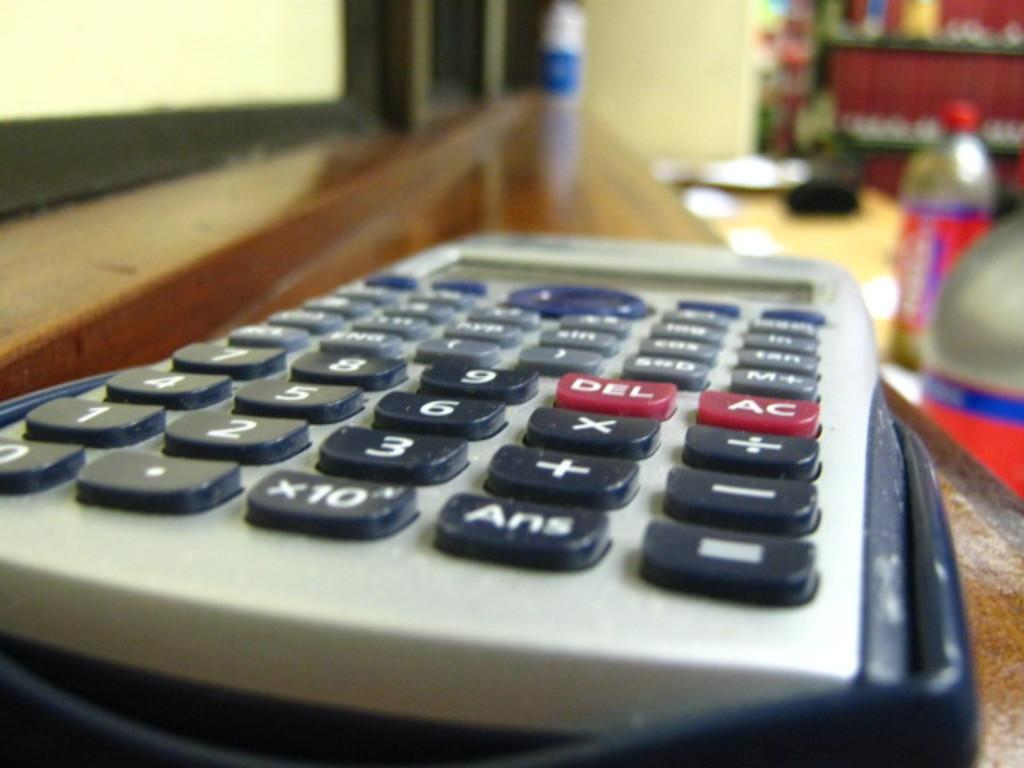<image>
Share a concise interpretation of the image provided. A close up of a calculator where the del and AC key can be seen. 